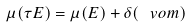Convert formula to latex. <formula><loc_0><loc_0><loc_500><loc_500>\mu ( \tau E ) = \mu ( E ) + \delta ( \ v o m )</formula> 